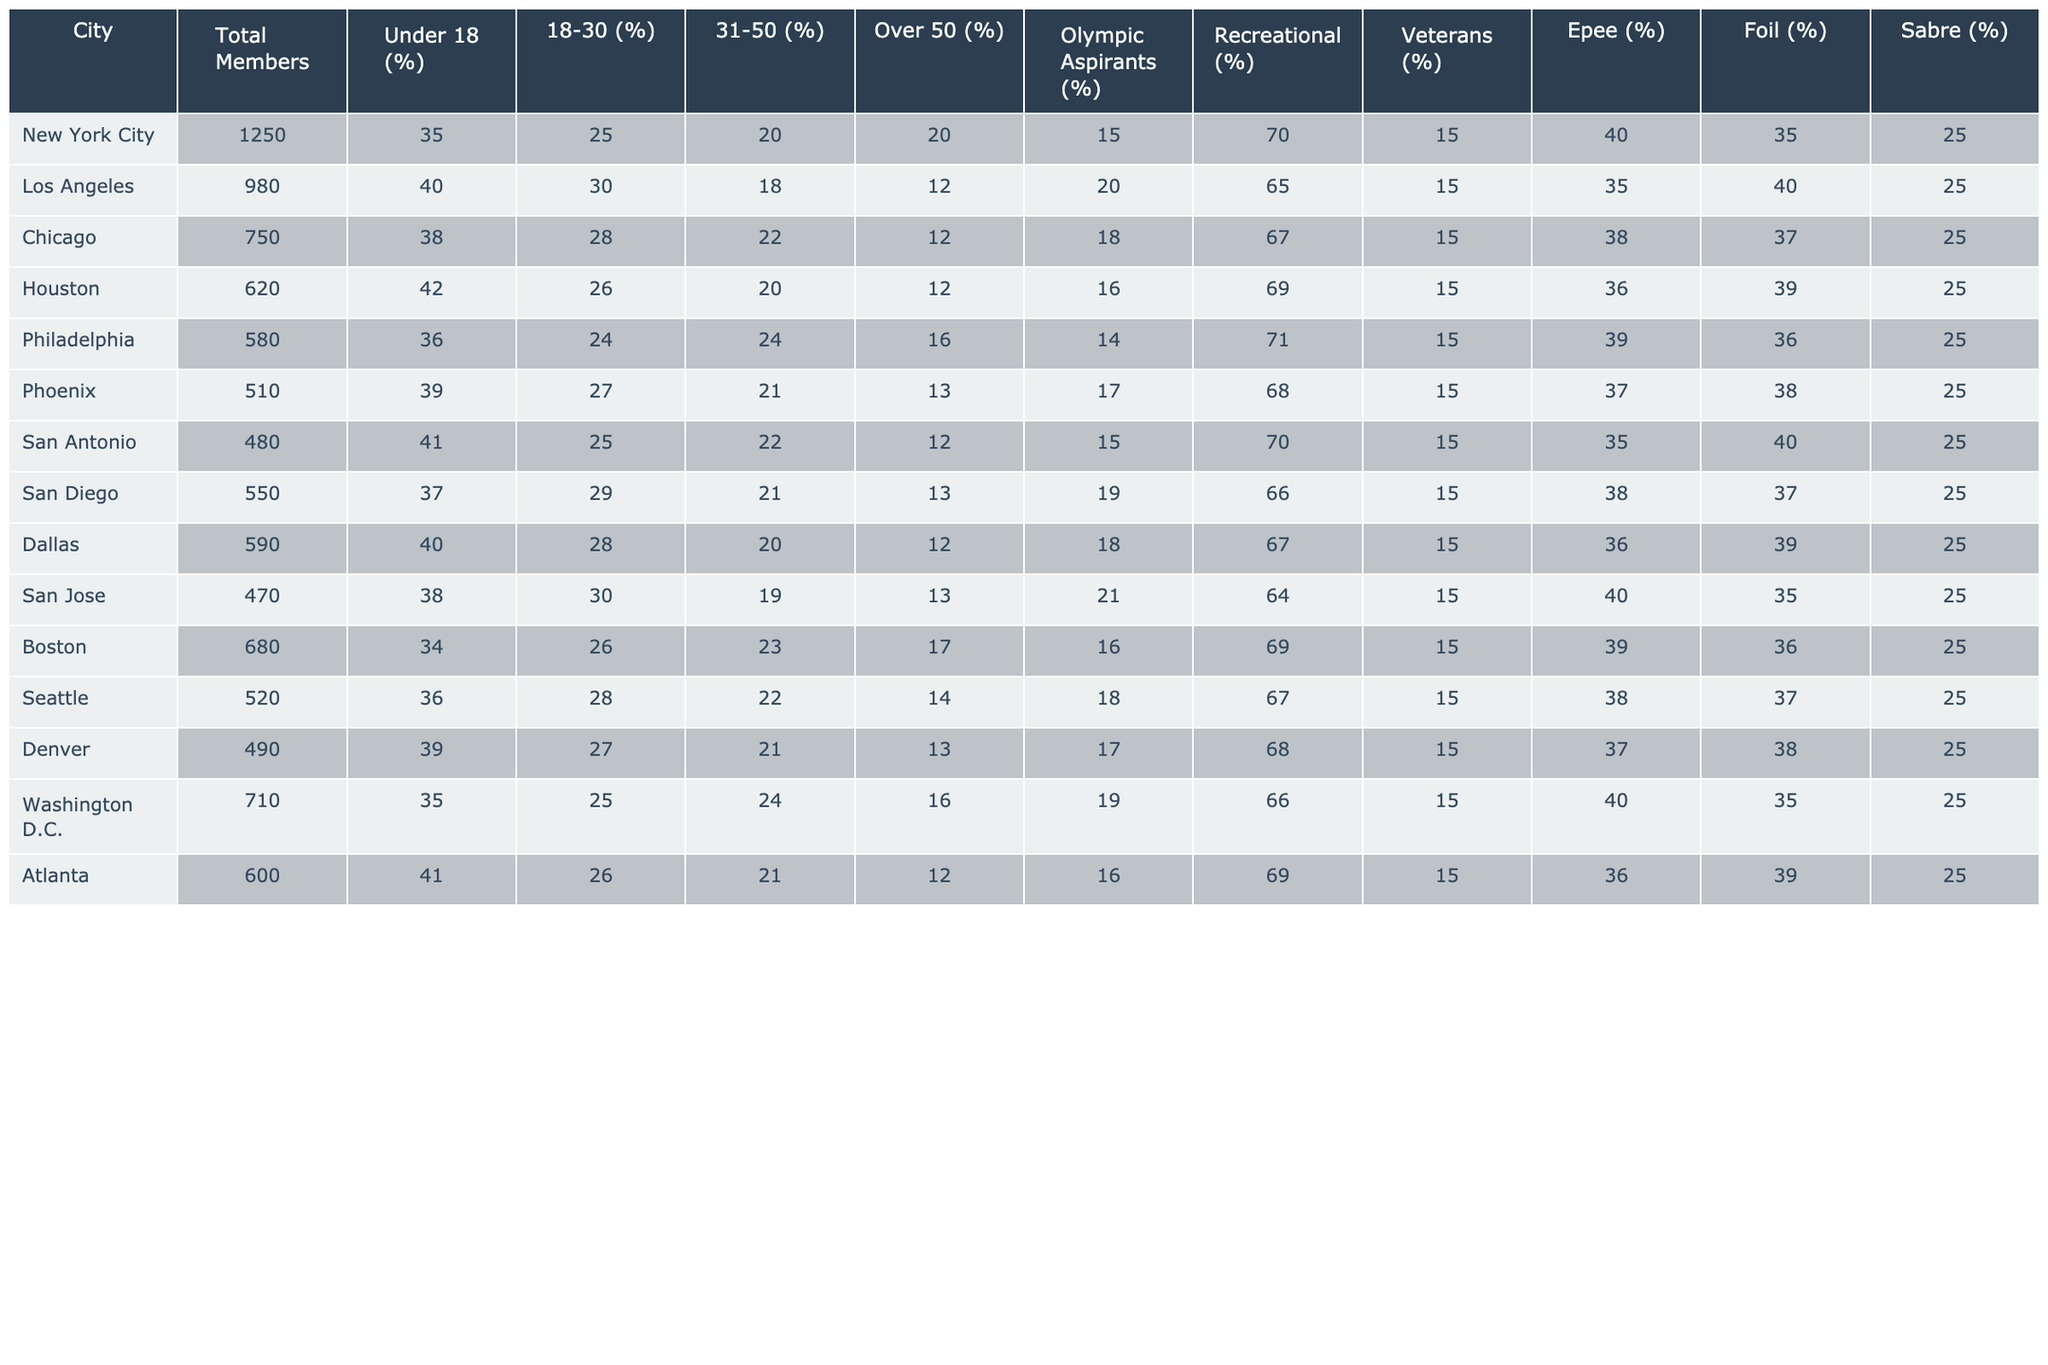What city has the highest percentage of members under 18? Looking at the column for "Under 18 (%)", Los Angeles has the highest percentage at 40%.
Answer: Los Angeles: 40% Which city has the lowest total members? By examining the "Total Members" column, San Antonio has the lowest total membership at 480 members.
Answer: San Antonio: 480 What is the average percentage of Olympic Aspirants across the cities? Summing the percentages of Olympic Aspirants: (15 + 20 + 18 + 16 + 14 + 17 + 15 + 19 + 18 + 21 + 16 + 19 + 16) = 224, and dividing by the number of cities (13) gives an average of 17.23%.
Answer: Approximately 17.23% Is the percentage of Recreational members in Chicago greater than that in Philadelphia? In Chicago, the percentage is 67%, while in Philadelphia it is 71%. Since 67% is less than 71%, the statement is false.
Answer: No What is the difference in the percentage of Foil members between New York City and Phoenix? For New York City, the Foil percentage is 40%, and for Phoenix, it is 37%. The difference is: 40% - 37% = 3%.
Answer: 3% Which city has the largest percentage of members aged 31-50? By observing the "31-50 (%)" column, Chicago has the largest percentage at 22%.
Answer: Chicago: 22% Is the percentage of veterans in the cities greater than 15%? All listed cities have a percentage of veterans at exactly 25% with none lower than this value, so the statement is true.
Answer: Yes What city has equal percentages of Epee and Sabre members? Examining the Epee and Sabre percentages, both are 25% in all cities, so there are no cities with differing values.
Answer: All cities equal: 25% Calculate the total percentage of members over 50 across all cities. Adding the percentages: (20 + 12 + 12 + 12 + 16 + 13 + 12 + 13 + 12 + 17 + 14 + 12) = 143%, dividing by the number of cities (13) gives approximately 11%.
Answer: Approximately 11% Which city has a higher percentage of members aged 18-30, and by how much? Comparing the percentages, Los Angeles has 30% and Chicago has 28%. Los Angeles exceeds Chicago by 2%.
Answer: Los Angeles by 2% 